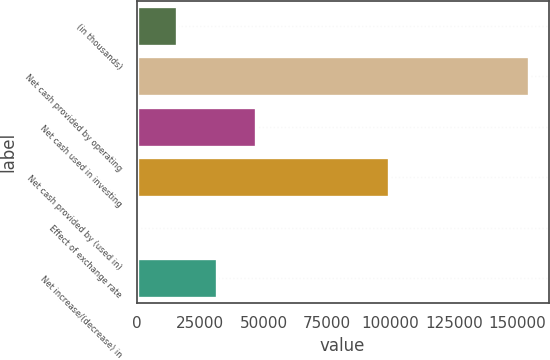Convert chart. <chart><loc_0><loc_0><loc_500><loc_500><bar_chart><fcel>(in thousands)<fcel>Net cash provided by operating<fcel>Net cash used in investing<fcel>Net cash provided by (used in)<fcel>Effect of exchange rate<fcel>Net increase/(decrease) in<nl><fcel>16098.3<fcel>154647<fcel>46886.9<fcel>99427<fcel>704<fcel>31492.6<nl></chart> 